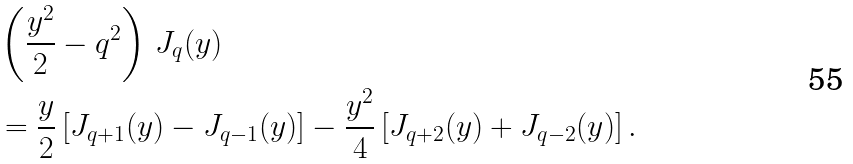Convert formula to latex. <formula><loc_0><loc_0><loc_500><loc_500>& \left ( \frac { y ^ { 2 } } { 2 } - q ^ { 2 } \right ) \, J _ { q } ( y ) \\ & = \frac { y } { 2 } \left [ J _ { q + 1 } ( y ) - J _ { q - 1 } ( y ) \right ] - \frac { y ^ { 2 } } { 4 } \left [ J _ { q + 2 } ( y ) + J _ { q - 2 } ( y ) \right ] .</formula> 